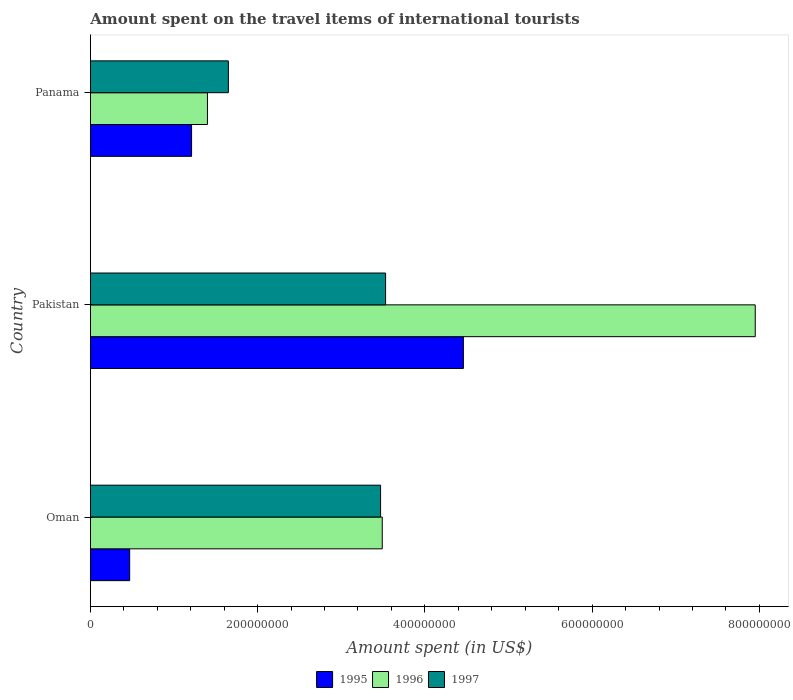How many different coloured bars are there?
Give a very brief answer. 3. How many groups of bars are there?
Give a very brief answer. 3. Are the number of bars on each tick of the Y-axis equal?
Provide a succinct answer. Yes. How many bars are there on the 1st tick from the top?
Provide a succinct answer. 3. What is the label of the 1st group of bars from the top?
Keep it short and to the point. Panama. What is the amount spent on the travel items of international tourists in 1995 in Pakistan?
Your response must be concise. 4.46e+08. Across all countries, what is the maximum amount spent on the travel items of international tourists in 1996?
Give a very brief answer. 7.95e+08. Across all countries, what is the minimum amount spent on the travel items of international tourists in 1997?
Your answer should be compact. 1.65e+08. In which country was the amount spent on the travel items of international tourists in 1997 maximum?
Provide a succinct answer. Pakistan. In which country was the amount spent on the travel items of international tourists in 1997 minimum?
Offer a very short reply. Panama. What is the total amount spent on the travel items of international tourists in 1997 in the graph?
Give a very brief answer. 8.65e+08. What is the difference between the amount spent on the travel items of international tourists in 1996 in Oman and that in Panama?
Ensure brevity in your answer.  2.09e+08. What is the difference between the amount spent on the travel items of international tourists in 1997 in Panama and the amount spent on the travel items of international tourists in 1995 in Pakistan?
Provide a short and direct response. -2.81e+08. What is the average amount spent on the travel items of international tourists in 1996 per country?
Your response must be concise. 4.28e+08. What is the difference between the amount spent on the travel items of international tourists in 1996 and amount spent on the travel items of international tourists in 1997 in Pakistan?
Offer a very short reply. 4.42e+08. In how many countries, is the amount spent on the travel items of international tourists in 1995 greater than 600000000 US$?
Give a very brief answer. 0. What is the ratio of the amount spent on the travel items of international tourists in 1995 in Pakistan to that in Panama?
Ensure brevity in your answer.  3.69. What is the difference between the highest and the lowest amount spent on the travel items of international tourists in 1995?
Make the answer very short. 3.99e+08. In how many countries, is the amount spent on the travel items of international tourists in 1997 greater than the average amount spent on the travel items of international tourists in 1997 taken over all countries?
Make the answer very short. 2. What does the 2nd bar from the top in Panama represents?
Provide a succinct answer. 1996. What does the 3rd bar from the bottom in Panama represents?
Keep it short and to the point. 1997. Is it the case that in every country, the sum of the amount spent on the travel items of international tourists in 1997 and amount spent on the travel items of international tourists in 1996 is greater than the amount spent on the travel items of international tourists in 1995?
Your response must be concise. Yes. How many bars are there?
Provide a short and direct response. 9. How many countries are there in the graph?
Make the answer very short. 3. What is the difference between two consecutive major ticks on the X-axis?
Your answer should be very brief. 2.00e+08. Where does the legend appear in the graph?
Provide a short and direct response. Bottom center. How are the legend labels stacked?
Keep it short and to the point. Horizontal. What is the title of the graph?
Your response must be concise. Amount spent on the travel items of international tourists. Does "2013" appear as one of the legend labels in the graph?
Offer a very short reply. No. What is the label or title of the X-axis?
Keep it short and to the point. Amount spent (in US$). What is the Amount spent (in US$) in 1995 in Oman?
Your answer should be very brief. 4.70e+07. What is the Amount spent (in US$) in 1996 in Oman?
Your response must be concise. 3.49e+08. What is the Amount spent (in US$) of 1997 in Oman?
Keep it short and to the point. 3.47e+08. What is the Amount spent (in US$) in 1995 in Pakistan?
Ensure brevity in your answer.  4.46e+08. What is the Amount spent (in US$) of 1996 in Pakistan?
Provide a short and direct response. 7.95e+08. What is the Amount spent (in US$) in 1997 in Pakistan?
Your answer should be very brief. 3.53e+08. What is the Amount spent (in US$) in 1995 in Panama?
Ensure brevity in your answer.  1.21e+08. What is the Amount spent (in US$) of 1996 in Panama?
Offer a very short reply. 1.40e+08. What is the Amount spent (in US$) of 1997 in Panama?
Your answer should be compact. 1.65e+08. Across all countries, what is the maximum Amount spent (in US$) in 1995?
Offer a very short reply. 4.46e+08. Across all countries, what is the maximum Amount spent (in US$) of 1996?
Make the answer very short. 7.95e+08. Across all countries, what is the maximum Amount spent (in US$) in 1997?
Keep it short and to the point. 3.53e+08. Across all countries, what is the minimum Amount spent (in US$) in 1995?
Your answer should be very brief. 4.70e+07. Across all countries, what is the minimum Amount spent (in US$) of 1996?
Provide a succinct answer. 1.40e+08. Across all countries, what is the minimum Amount spent (in US$) of 1997?
Ensure brevity in your answer.  1.65e+08. What is the total Amount spent (in US$) of 1995 in the graph?
Offer a very short reply. 6.14e+08. What is the total Amount spent (in US$) of 1996 in the graph?
Ensure brevity in your answer.  1.28e+09. What is the total Amount spent (in US$) of 1997 in the graph?
Your answer should be very brief. 8.65e+08. What is the difference between the Amount spent (in US$) of 1995 in Oman and that in Pakistan?
Keep it short and to the point. -3.99e+08. What is the difference between the Amount spent (in US$) in 1996 in Oman and that in Pakistan?
Provide a short and direct response. -4.46e+08. What is the difference between the Amount spent (in US$) in 1997 in Oman and that in Pakistan?
Provide a short and direct response. -6.00e+06. What is the difference between the Amount spent (in US$) of 1995 in Oman and that in Panama?
Provide a succinct answer. -7.40e+07. What is the difference between the Amount spent (in US$) of 1996 in Oman and that in Panama?
Your answer should be very brief. 2.09e+08. What is the difference between the Amount spent (in US$) in 1997 in Oman and that in Panama?
Your answer should be compact. 1.82e+08. What is the difference between the Amount spent (in US$) of 1995 in Pakistan and that in Panama?
Offer a terse response. 3.25e+08. What is the difference between the Amount spent (in US$) of 1996 in Pakistan and that in Panama?
Make the answer very short. 6.55e+08. What is the difference between the Amount spent (in US$) of 1997 in Pakistan and that in Panama?
Your answer should be compact. 1.88e+08. What is the difference between the Amount spent (in US$) of 1995 in Oman and the Amount spent (in US$) of 1996 in Pakistan?
Provide a succinct answer. -7.48e+08. What is the difference between the Amount spent (in US$) of 1995 in Oman and the Amount spent (in US$) of 1997 in Pakistan?
Provide a short and direct response. -3.06e+08. What is the difference between the Amount spent (in US$) in 1996 in Oman and the Amount spent (in US$) in 1997 in Pakistan?
Your answer should be very brief. -4.00e+06. What is the difference between the Amount spent (in US$) in 1995 in Oman and the Amount spent (in US$) in 1996 in Panama?
Ensure brevity in your answer.  -9.30e+07. What is the difference between the Amount spent (in US$) of 1995 in Oman and the Amount spent (in US$) of 1997 in Panama?
Offer a terse response. -1.18e+08. What is the difference between the Amount spent (in US$) in 1996 in Oman and the Amount spent (in US$) in 1997 in Panama?
Your response must be concise. 1.84e+08. What is the difference between the Amount spent (in US$) of 1995 in Pakistan and the Amount spent (in US$) of 1996 in Panama?
Give a very brief answer. 3.06e+08. What is the difference between the Amount spent (in US$) of 1995 in Pakistan and the Amount spent (in US$) of 1997 in Panama?
Provide a short and direct response. 2.81e+08. What is the difference between the Amount spent (in US$) in 1996 in Pakistan and the Amount spent (in US$) in 1997 in Panama?
Provide a succinct answer. 6.30e+08. What is the average Amount spent (in US$) in 1995 per country?
Keep it short and to the point. 2.05e+08. What is the average Amount spent (in US$) in 1996 per country?
Offer a terse response. 4.28e+08. What is the average Amount spent (in US$) of 1997 per country?
Make the answer very short. 2.88e+08. What is the difference between the Amount spent (in US$) of 1995 and Amount spent (in US$) of 1996 in Oman?
Provide a succinct answer. -3.02e+08. What is the difference between the Amount spent (in US$) of 1995 and Amount spent (in US$) of 1997 in Oman?
Keep it short and to the point. -3.00e+08. What is the difference between the Amount spent (in US$) in 1996 and Amount spent (in US$) in 1997 in Oman?
Provide a succinct answer. 2.00e+06. What is the difference between the Amount spent (in US$) in 1995 and Amount spent (in US$) in 1996 in Pakistan?
Provide a short and direct response. -3.49e+08. What is the difference between the Amount spent (in US$) in 1995 and Amount spent (in US$) in 1997 in Pakistan?
Provide a short and direct response. 9.30e+07. What is the difference between the Amount spent (in US$) of 1996 and Amount spent (in US$) of 1997 in Pakistan?
Your answer should be very brief. 4.42e+08. What is the difference between the Amount spent (in US$) of 1995 and Amount spent (in US$) of 1996 in Panama?
Provide a succinct answer. -1.90e+07. What is the difference between the Amount spent (in US$) of 1995 and Amount spent (in US$) of 1997 in Panama?
Ensure brevity in your answer.  -4.40e+07. What is the difference between the Amount spent (in US$) of 1996 and Amount spent (in US$) of 1997 in Panama?
Your answer should be very brief. -2.50e+07. What is the ratio of the Amount spent (in US$) in 1995 in Oman to that in Pakistan?
Your answer should be compact. 0.11. What is the ratio of the Amount spent (in US$) in 1996 in Oman to that in Pakistan?
Your answer should be compact. 0.44. What is the ratio of the Amount spent (in US$) of 1997 in Oman to that in Pakistan?
Your answer should be very brief. 0.98. What is the ratio of the Amount spent (in US$) in 1995 in Oman to that in Panama?
Give a very brief answer. 0.39. What is the ratio of the Amount spent (in US$) of 1996 in Oman to that in Panama?
Your answer should be compact. 2.49. What is the ratio of the Amount spent (in US$) in 1997 in Oman to that in Panama?
Offer a very short reply. 2.1. What is the ratio of the Amount spent (in US$) of 1995 in Pakistan to that in Panama?
Give a very brief answer. 3.69. What is the ratio of the Amount spent (in US$) of 1996 in Pakistan to that in Panama?
Your answer should be compact. 5.68. What is the ratio of the Amount spent (in US$) of 1997 in Pakistan to that in Panama?
Your answer should be very brief. 2.14. What is the difference between the highest and the second highest Amount spent (in US$) of 1995?
Give a very brief answer. 3.25e+08. What is the difference between the highest and the second highest Amount spent (in US$) of 1996?
Your answer should be compact. 4.46e+08. What is the difference between the highest and the second highest Amount spent (in US$) of 1997?
Keep it short and to the point. 6.00e+06. What is the difference between the highest and the lowest Amount spent (in US$) in 1995?
Provide a short and direct response. 3.99e+08. What is the difference between the highest and the lowest Amount spent (in US$) of 1996?
Provide a short and direct response. 6.55e+08. What is the difference between the highest and the lowest Amount spent (in US$) of 1997?
Keep it short and to the point. 1.88e+08. 